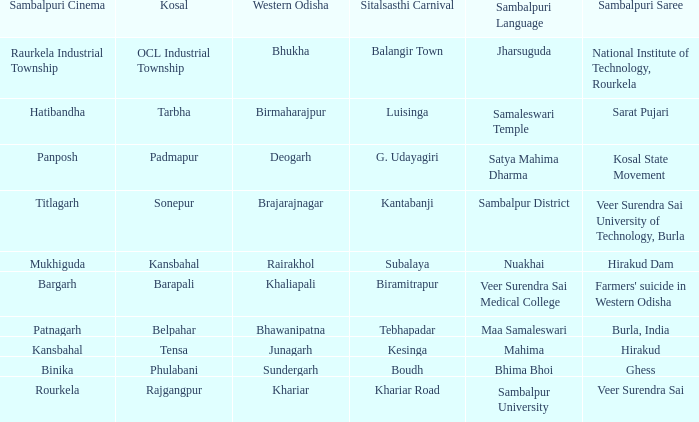What is the kosal with hatibandha as the sambalpuri cinema? Tarbha. 